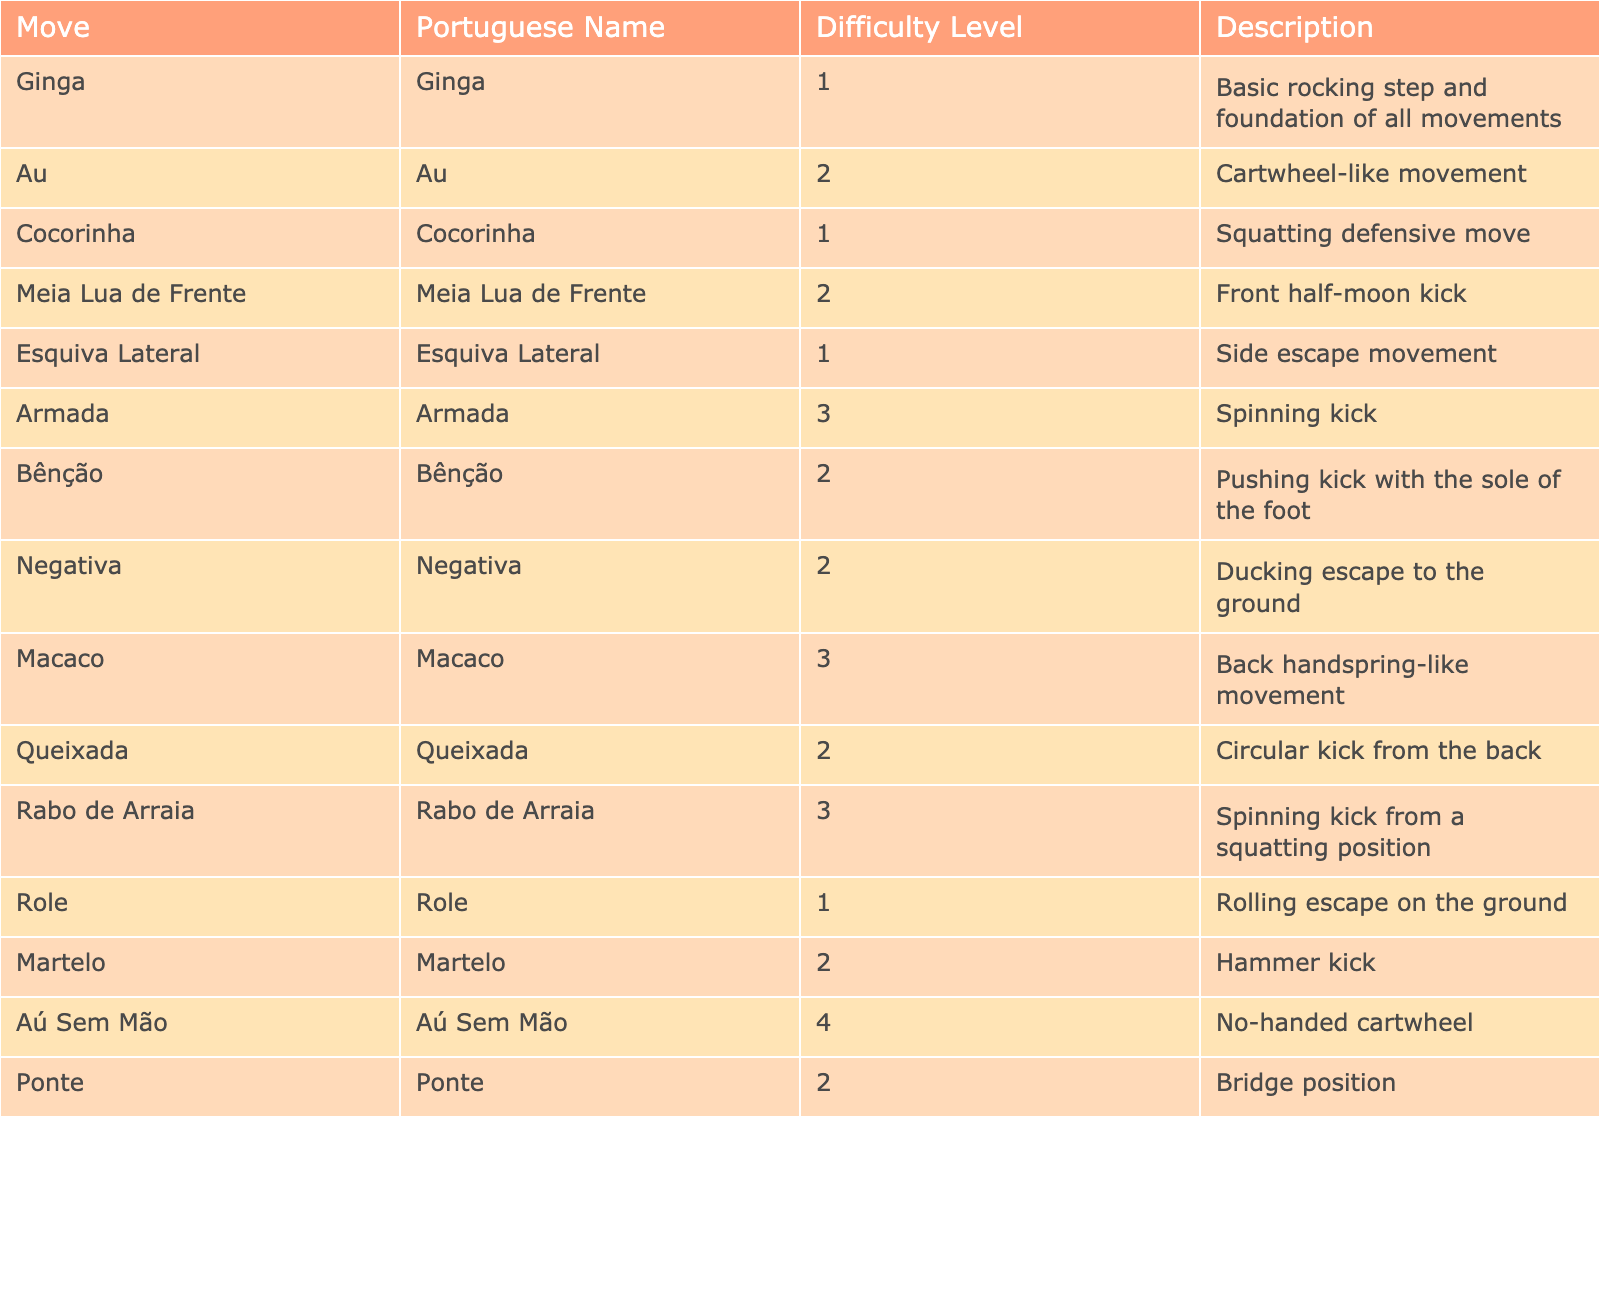What is the Portuguese name for the "Cocorinha" move? The table lists "Cocorinha" under the 'Move' column, which corresponds to the same name in the 'Portuguese Name' column.
Answer: Cocorinha Which move has the highest difficulty level? Looking at the 'Difficulty Level' column, the highest number is 4, corresponding to the "Aú Sem Mão" move.
Answer: Aú Sem Mão How many moves have a difficulty level of 2? By examining the table, I can count the moves with a difficulty level of 2: "Au," "Meia Lua de Frente," "Bênção," "Negativa," "Queixada," "Martelo," and "Ponte," making it a total of 7.
Answer: 7 Is "Role" a move with a difficulty level of 1? The 'Difficulty Level' column indicates that "Role" has a level of 1, confirming the statement is true.
Answer: Yes What is the average difficulty level of all the moves listed? Adding the difficulty levels (1+2+1+2+1+3+2+2+3+2+3+1+2+4) gives a total of 30. There are 14 moves, so the average is 30/14 ≈ 2.14.
Answer: Approximately 2.14 Which move is described as a back handspring-like movement? The description column lists "Back handspring-like movement," which belongs to the "Macaco" move.
Answer: Macaco What is the difference in difficulty level between "Rabo de Arraia" and "Cocorinha"? The difficulty level of "Rabo de Arraia" is 3 and "Cocorinha" is 1. The difference is 3 - 1 = 2.
Answer: 2 Are there more moves with a difficulty level of 3 than with a level of 1? The level 3 moves are "Armada," "Macaco," and "Rabo de Arraia" (3 moves), while level 1 moves are "Ginga," "Cocorinha," "Esquiva Lateral," "Role" (4 moves). Thus, the statement is false.
Answer: No Which move has the description of a "Spinning kick with the sole of the foot"? Searching the description column shows that the move with that description is "Bênção."
Answer: Bênção How many moves are categorized as defense escapes? The moves that fit that category are "Cocorinha," "Esquiva Lateral," "Negativa," and "Role," which gives a total of 4 defense escape moves.
Answer: 4 